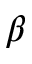<formula> <loc_0><loc_0><loc_500><loc_500>\beta</formula> 